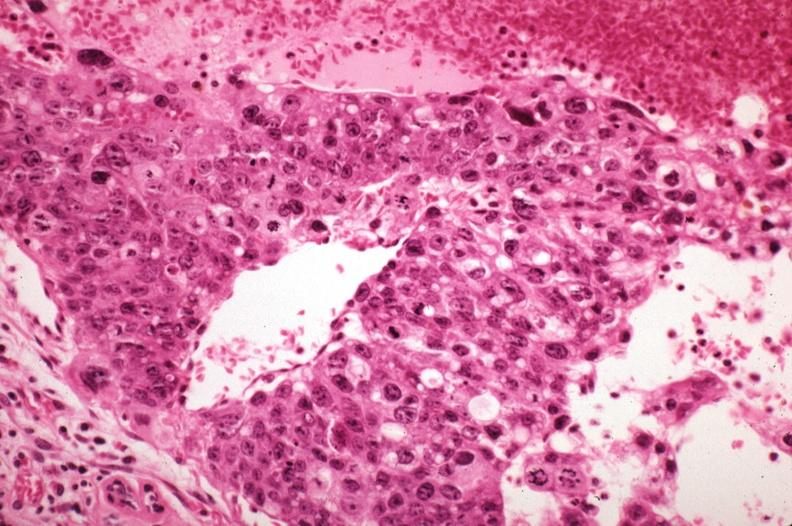s mesentery present?
Answer the question using a single word or phrase. No 